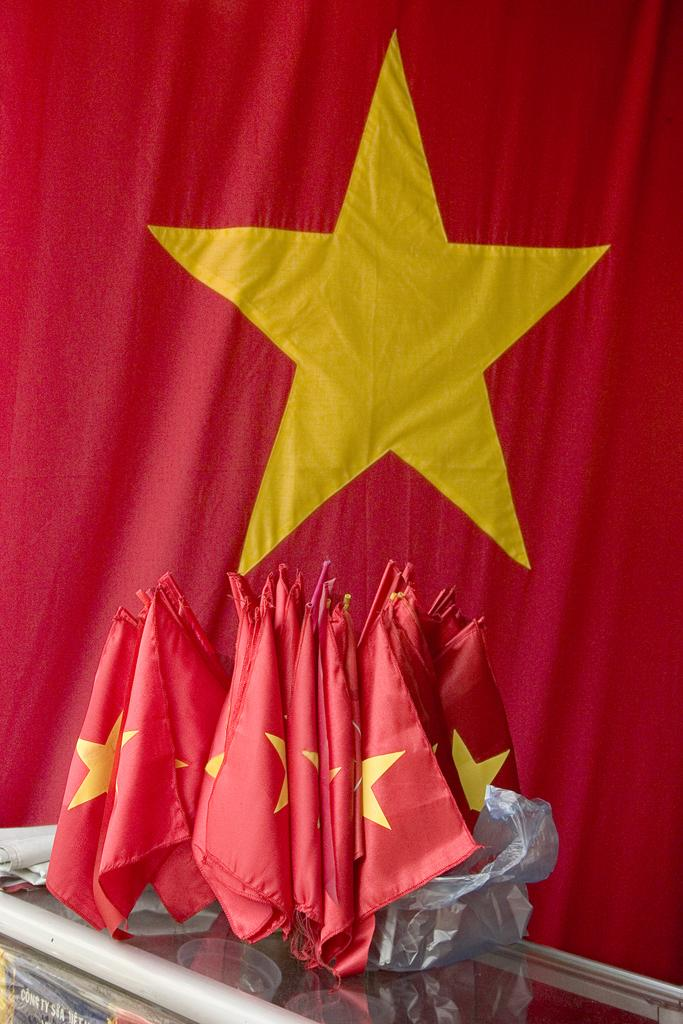What objects are on the table in the image? There are flags on a table in the image. Can you describe the size of one of the flags? There is a big flag visible in the image. What type of apparel is being worn by the snow in the image? There is no snow or apparel present in the image. What type of punishment is being administered to the flags in the image? There is no punishment being administered to the flags in the image. 